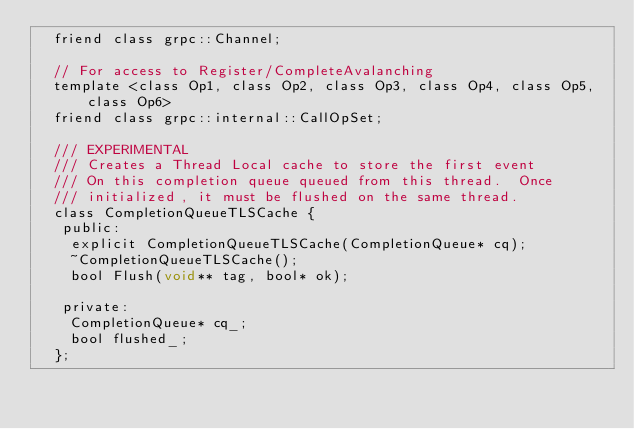<code> <loc_0><loc_0><loc_500><loc_500><_C_>  friend class grpc::Channel;

  // For access to Register/CompleteAvalanching
  template <class Op1, class Op2, class Op3, class Op4, class Op5, class Op6>
  friend class grpc::internal::CallOpSet;

  /// EXPERIMENTAL
  /// Creates a Thread Local cache to store the first event
  /// On this completion queue queued from this thread.  Once
  /// initialized, it must be flushed on the same thread.
  class CompletionQueueTLSCache {
   public:
    explicit CompletionQueueTLSCache(CompletionQueue* cq);
    ~CompletionQueueTLSCache();
    bool Flush(void** tag, bool* ok);

   private:
    CompletionQueue* cq_;
    bool flushed_;
  };
</code> 